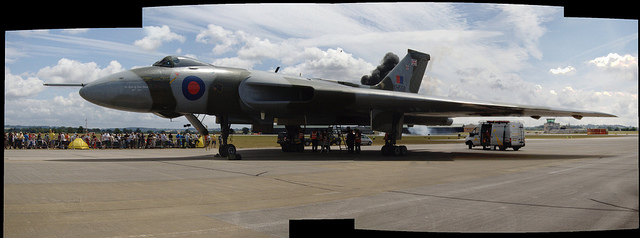<image>What does the word on the plane say? I am not sure what word is on the plane. It can be 'America', 'UK', 'Air Force', 'Korea', 'Royal Air Force', 'Jet', or 'USA'. What does the word on the plane say? I don't know what the word on the plane says. It can be 'america', 'uk', 'air force', 'korea', 'royal air force', 'jet', 'usa' or 'air force'. 